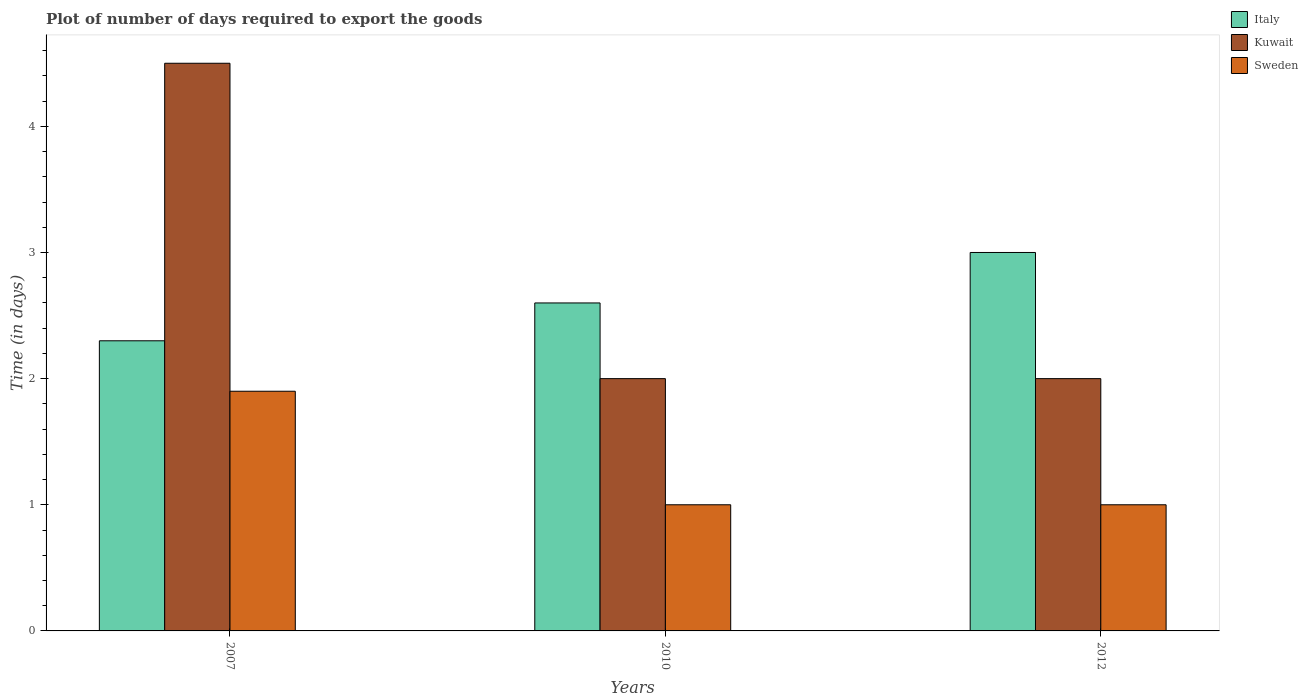How many different coloured bars are there?
Ensure brevity in your answer.  3. How many bars are there on the 2nd tick from the left?
Offer a terse response. 3. What is the label of the 2nd group of bars from the left?
Provide a succinct answer. 2010. In how many cases, is the number of bars for a given year not equal to the number of legend labels?
Your answer should be very brief. 0. What is the time required to export goods in Italy in 2010?
Your answer should be very brief. 2.6. Across all years, what is the maximum time required to export goods in Italy?
Your answer should be very brief. 3. In which year was the time required to export goods in Kuwait maximum?
Ensure brevity in your answer.  2007. In which year was the time required to export goods in Kuwait minimum?
Give a very brief answer. 2010. What is the total time required to export goods in Italy in the graph?
Keep it short and to the point. 7.9. What is the difference between the time required to export goods in Italy in 2007 and the time required to export goods in Kuwait in 2010?
Your answer should be very brief. 0.3. What is the average time required to export goods in Italy per year?
Provide a succinct answer. 2.63. What is the ratio of the time required to export goods in Kuwait in 2007 to that in 2012?
Your answer should be compact. 2.25. Is the time required to export goods in Sweden in 2007 less than that in 2012?
Offer a terse response. No. Is the difference between the time required to export goods in Kuwait in 2010 and 2012 greater than the difference between the time required to export goods in Sweden in 2010 and 2012?
Your answer should be very brief. No. What is the difference between the highest and the second highest time required to export goods in Italy?
Give a very brief answer. 0.4. What is the difference between the highest and the lowest time required to export goods in Sweden?
Offer a very short reply. 0.9. In how many years, is the time required to export goods in Kuwait greater than the average time required to export goods in Kuwait taken over all years?
Your answer should be compact. 1. What does the 2nd bar from the left in 2012 represents?
Your answer should be compact. Kuwait. What does the 1st bar from the right in 2012 represents?
Your response must be concise. Sweden. How many bars are there?
Your answer should be compact. 9. Are all the bars in the graph horizontal?
Offer a very short reply. No. How many years are there in the graph?
Keep it short and to the point. 3. What is the difference between two consecutive major ticks on the Y-axis?
Your answer should be very brief. 1. Does the graph contain any zero values?
Keep it short and to the point. No. What is the title of the graph?
Provide a succinct answer. Plot of number of days required to export the goods. Does "Marshall Islands" appear as one of the legend labels in the graph?
Offer a very short reply. No. What is the label or title of the Y-axis?
Your answer should be compact. Time (in days). What is the Time (in days) of Italy in 2007?
Provide a short and direct response. 2.3. What is the Time (in days) in Kuwait in 2007?
Make the answer very short. 4.5. What is the Time (in days) of Sweden in 2010?
Keep it short and to the point. 1. What is the Time (in days) of Kuwait in 2012?
Offer a very short reply. 2. Across all years, what is the minimum Time (in days) of Sweden?
Your response must be concise. 1. What is the total Time (in days) of Sweden in the graph?
Offer a very short reply. 3.9. What is the difference between the Time (in days) of Italy in 2007 and that in 2010?
Ensure brevity in your answer.  -0.3. What is the difference between the Time (in days) of Kuwait in 2007 and that in 2010?
Your response must be concise. 2.5. What is the difference between the Time (in days) in Sweden in 2007 and that in 2012?
Make the answer very short. 0.9. What is the difference between the Time (in days) in Italy in 2010 and that in 2012?
Offer a terse response. -0.4. What is the difference between the Time (in days) of Sweden in 2010 and that in 2012?
Your response must be concise. 0. What is the difference between the Time (in days) of Italy in 2007 and the Time (in days) of Kuwait in 2010?
Your answer should be compact. 0.3. What is the difference between the Time (in days) of Italy in 2007 and the Time (in days) of Sweden in 2010?
Your answer should be compact. 1.3. What is the difference between the Time (in days) in Italy in 2010 and the Time (in days) in Kuwait in 2012?
Your response must be concise. 0.6. What is the difference between the Time (in days) in Italy in 2010 and the Time (in days) in Sweden in 2012?
Provide a succinct answer. 1.6. What is the difference between the Time (in days) of Kuwait in 2010 and the Time (in days) of Sweden in 2012?
Ensure brevity in your answer.  1. What is the average Time (in days) in Italy per year?
Offer a terse response. 2.63. What is the average Time (in days) in Kuwait per year?
Keep it short and to the point. 2.83. What is the average Time (in days) of Sweden per year?
Provide a succinct answer. 1.3. In the year 2007, what is the difference between the Time (in days) in Italy and Time (in days) in Kuwait?
Ensure brevity in your answer.  -2.2. In the year 2007, what is the difference between the Time (in days) of Kuwait and Time (in days) of Sweden?
Your answer should be very brief. 2.6. In the year 2010, what is the difference between the Time (in days) of Kuwait and Time (in days) of Sweden?
Make the answer very short. 1. In the year 2012, what is the difference between the Time (in days) of Italy and Time (in days) of Kuwait?
Your answer should be very brief. 1. In the year 2012, what is the difference between the Time (in days) in Italy and Time (in days) in Sweden?
Provide a short and direct response. 2. What is the ratio of the Time (in days) in Italy in 2007 to that in 2010?
Make the answer very short. 0.88. What is the ratio of the Time (in days) of Kuwait in 2007 to that in 2010?
Give a very brief answer. 2.25. What is the ratio of the Time (in days) in Sweden in 2007 to that in 2010?
Your answer should be compact. 1.9. What is the ratio of the Time (in days) in Italy in 2007 to that in 2012?
Your response must be concise. 0.77. What is the ratio of the Time (in days) in Kuwait in 2007 to that in 2012?
Your response must be concise. 2.25. What is the ratio of the Time (in days) in Sweden in 2007 to that in 2012?
Ensure brevity in your answer.  1.9. What is the ratio of the Time (in days) in Italy in 2010 to that in 2012?
Your response must be concise. 0.87. What is the ratio of the Time (in days) of Kuwait in 2010 to that in 2012?
Keep it short and to the point. 1. What is the difference between the highest and the second highest Time (in days) of Kuwait?
Provide a succinct answer. 2.5. 